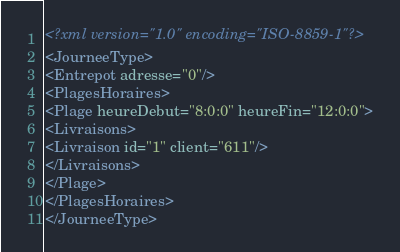<code> <loc_0><loc_0><loc_500><loc_500><_XML_><?xml version="1.0" encoding="ISO-8859-1"?>
<JourneeType>
<Entrepot adresse="0"/>
<PlagesHoraires>
<Plage heureDebut="8:0:0" heureFin="12:0:0">
<Livraisons>
<Livraison id="1" client="611"/>
</Livraisons>
</Plage>
</PlagesHoraires>
</JourneeType>
</code> 